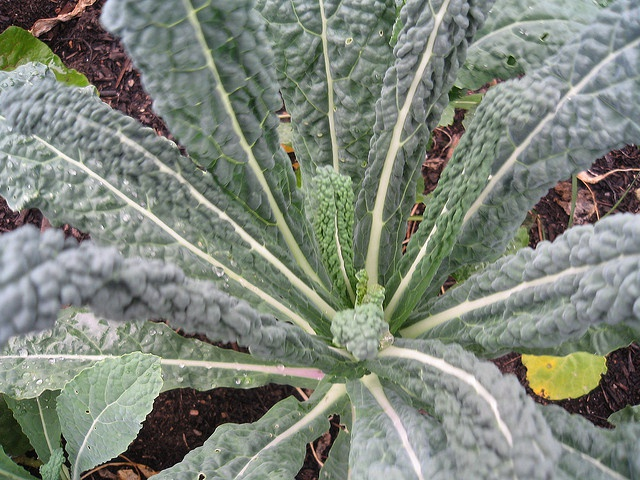Describe the objects in this image and their specific colors. I can see broccoli in brown, olive, green, and darkgray tones and broccoli in brown, darkgray, beige, and olive tones in this image. 